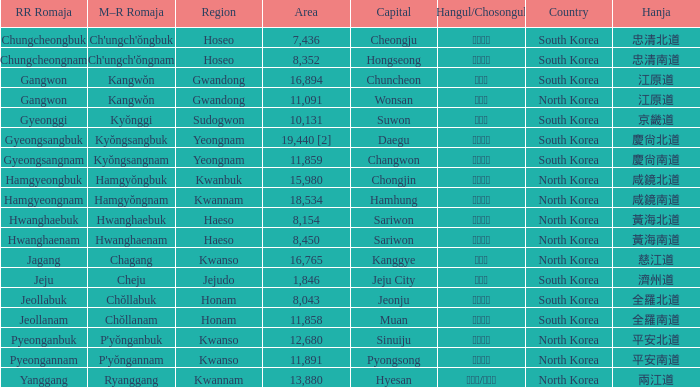Which capital has a Hangul of 경상남도? Changwon. 